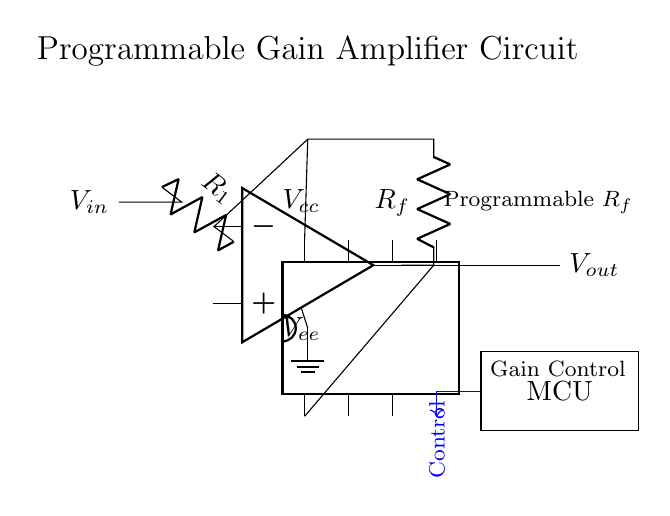What is the input voltage labeled in the circuit? The input voltage is represented by \( V_{in} \), shown on the left side of the circuit diagram.
Answer: \( V_{in} \) What is the component that adjusts the feedback resistor value? The digital potentiometer adjusts the feedback resistor value \( R_f \) as indicated in the circuit where it connects to the feedback path of the operational amplifier.
Answer: Digital potentiometer What kind of amplifier is this circuit representing? This circuit represents a programmable gain amplifier because it features a digital potentiometer allowing for adjustable gain settings through feedback resistance.
Answer: Programmable gain amplifier How many pins does the microcontroller have? The microcontroller is drawn as a rectangular block and does not explicitly show the number of pins, but in practical terms, it typically features multiple I/O pins connected to the digital potentiometer, which could vary; however, it is commonly depicted with eight pins for generic MCUs.
Answer: Eight What is the function of the control line in the circuit? The control line connects the microcontroller to the digital potentiometer for gain adjustment, allowing the microcontroller to dictate the value of the feedback resistor dynamically.
Answer: Gain adjustment What is the function of the operational amplifier in this circuit? The operational amplifier amplifies the input voltage based on the feedback from the digital potentiometer, thus providing a variable output voltage that corresponds to the input voltage and gain settings.
Answer: Amplification What are the power supply voltages for the operational amplifier? The circuit depicts two voltage supply connections, \( V_{cc} \) above the op-amp and \( V_{ee} \) below, typically representing the positive and negative supply voltages required for the op-amp's operation.
Answer: \( V_{cc} \) and \( V_{ee} \) 